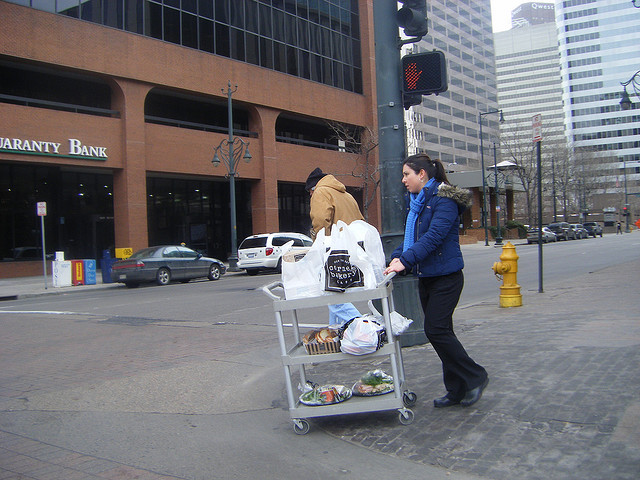Please identify all text content in this image. BANK JARANTY 